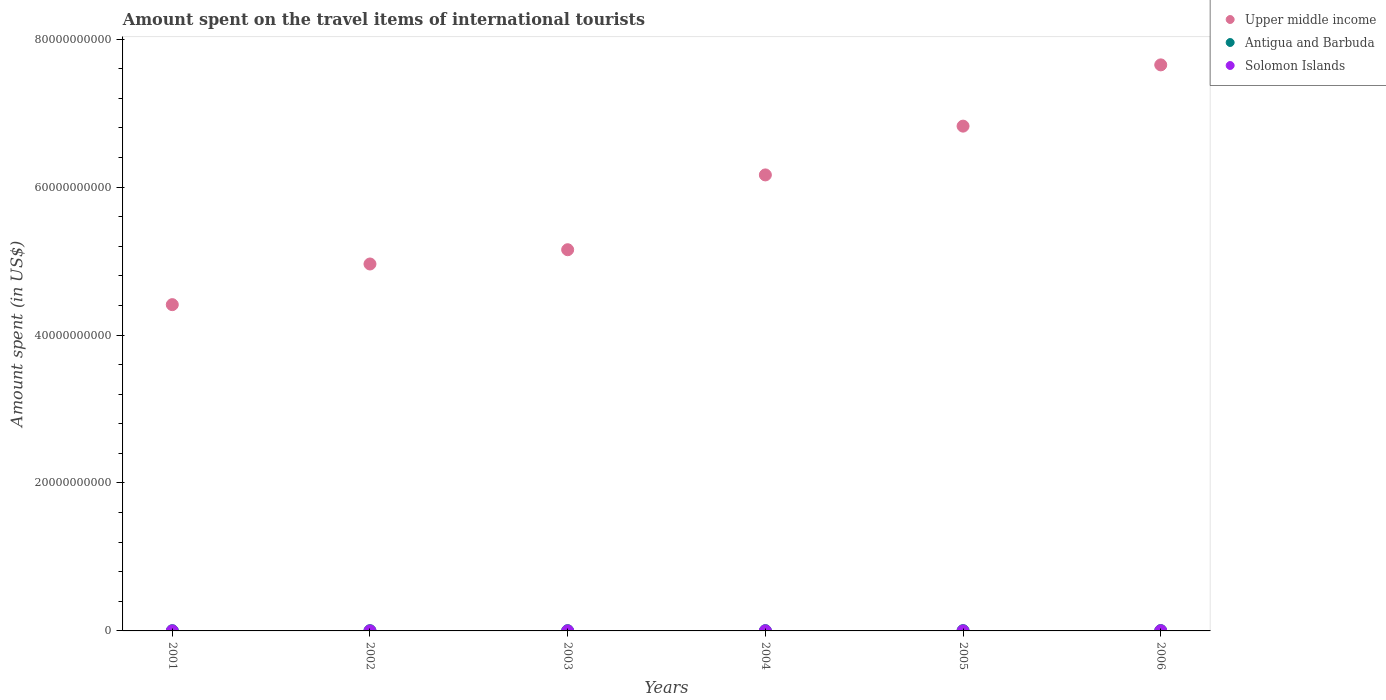What is the amount spent on the travel items of international tourists in Solomon Islands in 2001?
Keep it short and to the point. 6.60e+06. Across all years, what is the maximum amount spent on the travel items of international tourists in Antigua and Barbuda?
Ensure brevity in your answer.  4.50e+07. Across all years, what is the minimum amount spent on the travel items of international tourists in Solomon Islands?
Provide a short and direct response. 4.40e+06. In which year was the amount spent on the travel items of international tourists in Antigua and Barbuda minimum?
Your answer should be compact. 2001. What is the total amount spent on the travel items of international tourists in Antigua and Barbuda in the graph?
Your answer should be very brief. 2.23e+08. What is the difference between the amount spent on the travel items of international tourists in Upper middle income in 2005 and that in 2006?
Your answer should be compact. -8.28e+09. What is the difference between the amount spent on the travel items of international tourists in Antigua and Barbuda in 2004 and the amount spent on the travel items of international tourists in Upper middle income in 2001?
Your answer should be compact. -4.41e+1. What is the average amount spent on the travel items of international tourists in Solomon Islands per year?
Provide a short and direct response. 8.78e+06. In the year 2002, what is the difference between the amount spent on the travel items of international tourists in Solomon Islands and amount spent on the travel items of international tourists in Upper middle income?
Make the answer very short. -4.96e+1. Is the difference between the amount spent on the travel items of international tourists in Solomon Islands in 2003 and 2006 greater than the difference between the amount spent on the travel items of international tourists in Upper middle income in 2003 and 2006?
Your answer should be compact. Yes. What is the difference between the highest and the second highest amount spent on the travel items of international tourists in Upper middle income?
Offer a terse response. 8.28e+09. What is the difference between the highest and the lowest amount spent on the travel items of international tourists in Antigua and Barbuda?
Provide a short and direct response. 1.30e+07. In how many years, is the amount spent on the travel items of international tourists in Upper middle income greater than the average amount spent on the travel items of international tourists in Upper middle income taken over all years?
Ensure brevity in your answer.  3. Is it the case that in every year, the sum of the amount spent on the travel items of international tourists in Antigua and Barbuda and amount spent on the travel items of international tourists in Upper middle income  is greater than the amount spent on the travel items of international tourists in Solomon Islands?
Offer a very short reply. Yes. Does the amount spent on the travel items of international tourists in Upper middle income monotonically increase over the years?
Make the answer very short. Yes. Is the amount spent on the travel items of international tourists in Solomon Islands strictly greater than the amount spent on the travel items of international tourists in Upper middle income over the years?
Offer a terse response. No. How many years are there in the graph?
Ensure brevity in your answer.  6. What is the difference between two consecutive major ticks on the Y-axis?
Keep it short and to the point. 2.00e+1. Are the values on the major ticks of Y-axis written in scientific E-notation?
Ensure brevity in your answer.  No. Does the graph contain any zero values?
Provide a short and direct response. No. What is the title of the graph?
Your response must be concise. Amount spent on the travel items of international tourists. Does "Paraguay" appear as one of the legend labels in the graph?
Your answer should be compact. No. What is the label or title of the Y-axis?
Give a very brief answer. Amount spent (in US$). What is the Amount spent (in US$) of Upper middle income in 2001?
Keep it short and to the point. 4.41e+1. What is the Amount spent (in US$) in Antigua and Barbuda in 2001?
Your answer should be compact. 3.20e+07. What is the Amount spent (in US$) in Solomon Islands in 2001?
Keep it short and to the point. 6.60e+06. What is the Amount spent (in US$) of Upper middle income in 2002?
Provide a short and direct response. 4.96e+1. What is the Amount spent (in US$) of Antigua and Barbuda in 2002?
Provide a succinct answer. 3.30e+07. What is the Amount spent (in US$) of Solomon Islands in 2002?
Your answer should be compact. 5.80e+06. What is the Amount spent (in US$) in Upper middle income in 2003?
Provide a short and direct response. 5.15e+1. What is the Amount spent (in US$) in Antigua and Barbuda in 2003?
Ensure brevity in your answer.  3.50e+07. What is the Amount spent (in US$) in Solomon Islands in 2003?
Offer a very short reply. 4.40e+06. What is the Amount spent (in US$) of Upper middle income in 2004?
Provide a succinct answer. 6.16e+1. What is the Amount spent (in US$) in Antigua and Barbuda in 2004?
Offer a terse response. 3.80e+07. What is the Amount spent (in US$) of Solomon Islands in 2004?
Make the answer very short. 9.00e+06. What is the Amount spent (in US$) in Upper middle income in 2005?
Make the answer very short. 6.82e+1. What is the Amount spent (in US$) of Antigua and Barbuda in 2005?
Offer a very short reply. 4.00e+07. What is the Amount spent (in US$) of Solomon Islands in 2005?
Make the answer very short. 4.70e+06. What is the Amount spent (in US$) of Upper middle income in 2006?
Your response must be concise. 7.65e+1. What is the Amount spent (in US$) in Antigua and Barbuda in 2006?
Keep it short and to the point. 4.50e+07. What is the Amount spent (in US$) in Solomon Islands in 2006?
Your answer should be very brief. 2.22e+07. Across all years, what is the maximum Amount spent (in US$) of Upper middle income?
Give a very brief answer. 7.65e+1. Across all years, what is the maximum Amount spent (in US$) of Antigua and Barbuda?
Keep it short and to the point. 4.50e+07. Across all years, what is the maximum Amount spent (in US$) in Solomon Islands?
Give a very brief answer. 2.22e+07. Across all years, what is the minimum Amount spent (in US$) of Upper middle income?
Keep it short and to the point. 4.41e+1. Across all years, what is the minimum Amount spent (in US$) in Antigua and Barbuda?
Give a very brief answer. 3.20e+07. Across all years, what is the minimum Amount spent (in US$) of Solomon Islands?
Make the answer very short. 4.40e+06. What is the total Amount spent (in US$) in Upper middle income in the graph?
Provide a succinct answer. 3.52e+11. What is the total Amount spent (in US$) of Antigua and Barbuda in the graph?
Give a very brief answer. 2.23e+08. What is the total Amount spent (in US$) in Solomon Islands in the graph?
Offer a very short reply. 5.27e+07. What is the difference between the Amount spent (in US$) of Upper middle income in 2001 and that in 2002?
Make the answer very short. -5.50e+09. What is the difference between the Amount spent (in US$) of Antigua and Barbuda in 2001 and that in 2002?
Ensure brevity in your answer.  -1.00e+06. What is the difference between the Amount spent (in US$) in Solomon Islands in 2001 and that in 2002?
Your answer should be very brief. 8.00e+05. What is the difference between the Amount spent (in US$) in Upper middle income in 2001 and that in 2003?
Provide a succinct answer. -7.43e+09. What is the difference between the Amount spent (in US$) of Antigua and Barbuda in 2001 and that in 2003?
Provide a short and direct response. -3.00e+06. What is the difference between the Amount spent (in US$) of Solomon Islands in 2001 and that in 2003?
Give a very brief answer. 2.20e+06. What is the difference between the Amount spent (in US$) in Upper middle income in 2001 and that in 2004?
Keep it short and to the point. -1.75e+1. What is the difference between the Amount spent (in US$) of Antigua and Barbuda in 2001 and that in 2004?
Offer a terse response. -6.00e+06. What is the difference between the Amount spent (in US$) in Solomon Islands in 2001 and that in 2004?
Offer a terse response. -2.40e+06. What is the difference between the Amount spent (in US$) in Upper middle income in 2001 and that in 2005?
Your answer should be very brief. -2.41e+1. What is the difference between the Amount spent (in US$) of Antigua and Barbuda in 2001 and that in 2005?
Your answer should be compact. -8.00e+06. What is the difference between the Amount spent (in US$) in Solomon Islands in 2001 and that in 2005?
Ensure brevity in your answer.  1.90e+06. What is the difference between the Amount spent (in US$) in Upper middle income in 2001 and that in 2006?
Give a very brief answer. -3.24e+1. What is the difference between the Amount spent (in US$) in Antigua and Barbuda in 2001 and that in 2006?
Provide a short and direct response. -1.30e+07. What is the difference between the Amount spent (in US$) in Solomon Islands in 2001 and that in 2006?
Provide a short and direct response. -1.56e+07. What is the difference between the Amount spent (in US$) in Upper middle income in 2002 and that in 2003?
Ensure brevity in your answer.  -1.93e+09. What is the difference between the Amount spent (in US$) in Solomon Islands in 2002 and that in 2003?
Provide a succinct answer. 1.40e+06. What is the difference between the Amount spent (in US$) in Upper middle income in 2002 and that in 2004?
Provide a succinct answer. -1.20e+1. What is the difference between the Amount spent (in US$) in Antigua and Barbuda in 2002 and that in 2004?
Your response must be concise. -5.00e+06. What is the difference between the Amount spent (in US$) of Solomon Islands in 2002 and that in 2004?
Provide a succinct answer. -3.20e+06. What is the difference between the Amount spent (in US$) in Upper middle income in 2002 and that in 2005?
Provide a succinct answer. -1.86e+1. What is the difference between the Amount spent (in US$) in Antigua and Barbuda in 2002 and that in 2005?
Ensure brevity in your answer.  -7.00e+06. What is the difference between the Amount spent (in US$) in Solomon Islands in 2002 and that in 2005?
Your answer should be compact. 1.10e+06. What is the difference between the Amount spent (in US$) of Upper middle income in 2002 and that in 2006?
Provide a succinct answer. -2.69e+1. What is the difference between the Amount spent (in US$) of Antigua and Barbuda in 2002 and that in 2006?
Offer a terse response. -1.20e+07. What is the difference between the Amount spent (in US$) of Solomon Islands in 2002 and that in 2006?
Your answer should be compact. -1.64e+07. What is the difference between the Amount spent (in US$) of Upper middle income in 2003 and that in 2004?
Your response must be concise. -1.01e+1. What is the difference between the Amount spent (in US$) of Antigua and Barbuda in 2003 and that in 2004?
Offer a very short reply. -3.00e+06. What is the difference between the Amount spent (in US$) in Solomon Islands in 2003 and that in 2004?
Ensure brevity in your answer.  -4.60e+06. What is the difference between the Amount spent (in US$) in Upper middle income in 2003 and that in 2005?
Your answer should be compact. -1.67e+1. What is the difference between the Amount spent (in US$) in Antigua and Barbuda in 2003 and that in 2005?
Your answer should be very brief. -5.00e+06. What is the difference between the Amount spent (in US$) of Upper middle income in 2003 and that in 2006?
Your answer should be very brief. -2.50e+1. What is the difference between the Amount spent (in US$) of Antigua and Barbuda in 2003 and that in 2006?
Keep it short and to the point. -1.00e+07. What is the difference between the Amount spent (in US$) of Solomon Islands in 2003 and that in 2006?
Provide a succinct answer. -1.78e+07. What is the difference between the Amount spent (in US$) in Upper middle income in 2004 and that in 2005?
Give a very brief answer. -6.59e+09. What is the difference between the Amount spent (in US$) of Antigua and Barbuda in 2004 and that in 2005?
Make the answer very short. -2.00e+06. What is the difference between the Amount spent (in US$) in Solomon Islands in 2004 and that in 2005?
Provide a succinct answer. 4.30e+06. What is the difference between the Amount spent (in US$) of Upper middle income in 2004 and that in 2006?
Provide a short and direct response. -1.49e+1. What is the difference between the Amount spent (in US$) of Antigua and Barbuda in 2004 and that in 2006?
Provide a short and direct response. -7.00e+06. What is the difference between the Amount spent (in US$) in Solomon Islands in 2004 and that in 2006?
Keep it short and to the point. -1.32e+07. What is the difference between the Amount spent (in US$) of Upper middle income in 2005 and that in 2006?
Ensure brevity in your answer.  -8.28e+09. What is the difference between the Amount spent (in US$) in Antigua and Barbuda in 2005 and that in 2006?
Your answer should be compact. -5.00e+06. What is the difference between the Amount spent (in US$) of Solomon Islands in 2005 and that in 2006?
Your response must be concise. -1.75e+07. What is the difference between the Amount spent (in US$) of Upper middle income in 2001 and the Amount spent (in US$) of Antigua and Barbuda in 2002?
Your answer should be very brief. 4.41e+1. What is the difference between the Amount spent (in US$) in Upper middle income in 2001 and the Amount spent (in US$) in Solomon Islands in 2002?
Your answer should be very brief. 4.41e+1. What is the difference between the Amount spent (in US$) in Antigua and Barbuda in 2001 and the Amount spent (in US$) in Solomon Islands in 2002?
Make the answer very short. 2.62e+07. What is the difference between the Amount spent (in US$) in Upper middle income in 2001 and the Amount spent (in US$) in Antigua and Barbuda in 2003?
Provide a succinct answer. 4.41e+1. What is the difference between the Amount spent (in US$) of Upper middle income in 2001 and the Amount spent (in US$) of Solomon Islands in 2003?
Provide a succinct answer. 4.41e+1. What is the difference between the Amount spent (in US$) in Antigua and Barbuda in 2001 and the Amount spent (in US$) in Solomon Islands in 2003?
Ensure brevity in your answer.  2.76e+07. What is the difference between the Amount spent (in US$) in Upper middle income in 2001 and the Amount spent (in US$) in Antigua and Barbuda in 2004?
Your answer should be very brief. 4.41e+1. What is the difference between the Amount spent (in US$) in Upper middle income in 2001 and the Amount spent (in US$) in Solomon Islands in 2004?
Offer a very short reply. 4.41e+1. What is the difference between the Amount spent (in US$) of Antigua and Barbuda in 2001 and the Amount spent (in US$) of Solomon Islands in 2004?
Keep it short and to the point. 2.30e+07. What is the difference between the Amount spent (in US$) of Upper middle income in 2001 and the Amount spent (in US$) of Antigua and Barbuda in 2005?
Make the answer very short. 4.41e+1. What is the difference between the Amount spent (in US$) of Upper middle income in 2001 and the Amount spent (in US$) of Solomon Islands in 2005?
Make the answer very short. 4.41e+1. What is the difference between the Amount spent (in US$) in Antigua and Barbuda in 2001 and the Amount spent (in US$) in Solomon Islands in 2005?
Keep it short and to the point. 2.73e+07. What is the difference between the Amount spent (in US$) in Upper middle income in 2001 and the Amount spent (in US$) in Antigua and Barbuda in 2006?
Offer a terse response. 4.41e+1. What is the difference between the Amount spent (in US$) of Upper middle income in 2001 and the Amount spent (in US$) of Solomon Islands in 2006?
Provide a short and direct response. 4.41e+1. What is the difference between the Amount spent (in US$) in Antigua and Barbuda in 2001 and the Amount spent (in US$) in Solomon Islands in 2006?
Offer a very short reply. 9.80e+06. What is the difference between the Amount spent (in US$) in Upper middle income in 2002 and the Amount spent (in US$) in Antigua and Barbuda in 2003?
Ensure brevity in your answer.  4.96e+1. What is the difference between the Amount spent (in US$) of Upper middle income in 2002 and the Amount spent (in US$) of Solomon Islands in 2003?
Make the answer very short. 4.96e+1. What is the difference between the Amount spent (in US$) in Antigua and Barbuda in 2002 and the Amount spent (in US$) in Solomon Islands in 2003?
Your answer should be compact. 2.86e+07. What is the difference between the Amount spent (in US$) in Upper middle income in 2002 and the Amount spent (in US$) in Antigua and Barbuda in 2004?
Give a very brief answer. 4.96e+1. What is the difference between the Amount spent (in US$) of Upper middle income in 2002 and the Amount spent (in US$) of Solomon Islands in 2004?
Your response must be concise. 4.96e+1. What is the difference between the Amount spent (in US$) of Antigua and Barbuda in 2002 and the Amount spent (in US$) of Solomon Islands in 2004?
Your response must be concise. 2.40e+07. What is the difference between the Amount spent (in US$) of Upper middle income in 2002 and the Amount spent (in US$) of Antigua and Barbuda in 2005?
Make the answer very short. 4.96e+1. What is the difference between the Amount spent (in US$) in Upper middle income in 2002 and the Amount spent (in US$) in Solomon Islands in 2005?
Provide a short and direct response. 4.96e+1. What is the difference between the Amount spent (in US$) of Antigua and Barbuda in 2002 and the Amount spent (in US$) of Solomon Islands in 2005?
Make the answer very short. 2.83e+07. What is the difference between the Amount spent (in US$) in Upper middle income in 2002 and the Amount spent (in US$) in Antigua and Barbuda in 2006?
Your answer should be very brief. 4.96e+1. What is the difference between the Amount spent (in US$) in Upper middle income in 2002 and the Amount spent (in US$) in Solomon Islands in 2006?
Offer a very short reply. 4.96e+1. What is the difference between the Amount spent (in US$) in Antigua and Barbuda in 2002 and the Amount spent (in US$) in Solomon Islands in 2006?
Give a very brief answer. 1.08e+07. What is the difference between the Amount spent (in US$) of Upper middle income in 2003 and the Amount spent (in US$) of Antigua and Barbuda in 2004?
Make the answer very short. 5.15e+1. What is the difference between the Amount spent (in US$) of Upper middle income in 2003 and the Amount spent (in US$) of Solomon Islands in 2004?
Provide a succinct answer. 5.15e+1. What is the difference between the Amount spent (in US$) of Antigua and Barbuda in 2003 and the Amount spent (in US$) of Solomon Islands in 2004?
Your response must be concise. 2.60e+07. What is the difference between the Amount spent (in US$) of Upper middle income in 2003 and the Amount spent (in US$) of Antigua and Barbuda in 2005?
Your answer should be very brief. 5.15e+1. What is the difference between the Amount spent (in US$) in Upper middle income in 2003 and the Amount spent (in US$) in Solomon Islands in 2005?
Your response must be concise. 5.15e+1. What is the difference between the Amount spent (in US$) of Antigua and Barbuda in 2003 and the Amount spent (in US$) of Solomon Islands in 2005?
Your answer should be compact. 3.03e+07. What is the difference between the Amount spent (in US$) in Upper middle income in 2003 and the Amount spent (in US$) in Antigua and Barbuda in 2006?
Provide a short and direct response. 5.15e+1. What is the difference between the Amount spent (in US$) of Upper middle income in 2003 and the Amount spent (in US$) of Solomon Islands in 2006?
Make the answer very short. 5.15e+1. What is the difference between the Amount spent (in US$) in Antigua and Barbuda in 2003 and the Amount spent (in US$) in Solomon Islands in 2006?
Offer a very short reply. 1.28e+07. What is the difference between the Amount spent (in US$) of Upper middle income in 2004 and the Amount spent (in US$) of Antigua and Barbuda in 2005?
Your response must be concise. 6.16e+1. What is the difference between the Amount spent (in US$) of Upper middle income in 2004 and the Amount spent (in US$) of Solomon Islands in 2005?
Your response must be concise. 6.16e+1. What is the difference between the Amount spent (in US$) of Antigua and Barbuda in 2004 and the Amount spent (in US$) of Solomon Islands in 2005?
Offer a very short reply. 3.33e+07. What is the difference between the Amount spent (in US$) in Upper middle income in 2004 and the Amount spent (in US$) in Antigua and Barbuda in 2006?
Make the answer very short. 6.16e+1. What is the difference between the Amount spent (in US$) of Upper middle income in 2004 and the Amount spent (in US$) of Solomon Islands in 2006?
Make the answer very short. 6.16e+1. What is the difference between the Amount spent (in US$) in Antigua and Barbuda in 2004 and the Amount spent (in US$) in Solomon Islands in 2006?
Ensure brevity in your answer.  1.58e+07. What is the difference between the Amount spent (in US$) of Upper middle income in 2005 and the Amount spent (in US$) of Antigua and Barbuda in 2006?
Offer a terse response. 6.82e+1. What is the difference between the Amount spent (in US$) of Upper middle income in 2005 and the Amount spent (in US$) of Solomon Islands in 2006?
Keep it short and to the point. 6.82e+1. What is the difference between the Amount spent (in US$) of Antigua and Barbuda in 2005 and the Amount spent (in US$) of Solomon Islands in 2006?
Offer a very short reply. 1.78e+07. What is the average Amount spent (in US$) of Upper middle income per year?
Your response must be concise. 5.86e+1. What is the average Amount spent (in US$) in Antigua and Barbuda per year?
Ensure brevity in your answer.  3.72e+07. What is the average Amount spent (in US$) of Solomon Islands per year?
Your response must be concise. 8.78e+06. In the year 2001, what is the difference between the Amount spent (in US$) in Upper middle income and Amount spent (in US$) in Antigua and Barbuda?
Your answer should be compact. 4.41e+1. In the year 2001, what is the difference between the Amount spent (in US$) of Upper middle income and Amount spent (in US$) of Solomon Islands?
Offer a terse response. 4.41e+1. In the year 2001, what is the difference between the Amount spent (in US$) in Antigua and Barbuda and Amount spent (in US$) in Solomon Islands?
Provide a succinct answer. 2.54e+07. In the year 2002, what is the difference between the Amount spent (in US$) of Upper middle income and Amount spent (in US$) of Antigua and Barbuda?
Your answer should be very brief. 4.96e+1. In the year 2002, what is the difference between the Amount spent (in US$) of Upper middle income and Amount spent (in US$) of Solomon Islands?
Provide a succinct answer. 4.96e+1. In the year 2002, what is the difference between the Amount spent (in US$) of Antigua and Barbuda and Amount spent (in US$) of Solomon Islands?
Your response must be concise. 2.72e+07. In the year 2003, what is the difference between the Amount spent (in US$) of Upper middle income and Amount spent (in US$) of Antigua and Barbuda?
Your response must be concise. 5.15e+1. In the year 2003, what is the difference between the Amount spent (in US$) in Upper middle income and Amount spent (in US$) in Solomon Islands?
Give a very brief answer. 5.15e+1. In the year 2003, what is the difference between the Amount spent (in US$) in Antigua and Barbuda and Amount spent (in US$) in Solomon Islands?
Provide a succinct answer. 3.06e+07. In the year 2004, what is the difference between the Amount spent (in US$) in Upper middle income and Amount spent (in US$) in Antigua and Barbuda?
Your answer should be compact. 6.16e+1. In the year 2004, what is the difference between the Amount spent (in US$) of Upper middle income and Amount spent (in US$) of Solomon Islands?
Provide a succinct answer. 6.16e+1. In the year 2004, what is the difference between the Amount spent (in US$) in Antigua and Barbuda and Amount spent (in US$) in Solomon Islands?
Give a very brief answer. 2.90e+07. In the year 2005, what is the difference between the Amount spent (in US$) of Upper middle income and Amount spent (in US$) of Antigua and Barbuda?
Offer a very short reply. 6.82e+1. In the year 2005, what is the difference between the Amount spent (in US$) in Upper middle income and Amount spent (in US$) in Solomon Islands?
Provide a succinct answer. 6.82e+1. In the year 2005, what is the difference between the Amount spent (in US$) of Antigua and Barbuda and Amount spent (in US$) of Solomon Islands?
Your answer should be very brief. 3.53e+07. In the year 2006, what is the difference between the Amount spent (in US$) in Upper middle income and Amount spent (in US$) in Antigua and Barbuda?
Ensure brevity in your answer.  7.65e+1. In the year 2006, what is the difference between the Amount spent (in US$) in Upper middle income and Amount spent (in US$) in Solomon Islands?
Offer a terse response. 7.65e+1. In the year 2006, what is the difference between the Amount spent (in US$) in Antigua and Barbuda and Amount spent (in US$) in Solomon Islands?
Keep it short and to the point. 2.28e+07. What is the ratio of the Amount spent (in US$) in Upper middle income in 2001 to that in 2002?
Provide a succinct answer. 0.89. What is the ratio of the Amount spent (in US$) of Antigua and Barbuda in 2001 to that in 2002?
Your answer should be very brief. 0.97. What is the ratio of the Amount spent (in US$) in Solomon Islands in 2001 to that in 2002?
Make the answer very short. 1.14. What is the ratio of the Amount spent (in US$) in Upper middle income in 2001 to that in 2003?
Ensure brevity in your answer.  0.86. What is the ratio of the Amount spent (in US$) in Antigua and Barbuda in 2001 to that in 2003?
Your response must be concise. 0.91. What is the ratio of the Amount spent (in US$) in Upper middle income in 2001 to that in 2004?
Offer a terse response. 0.72. What is the ratio of the Amount spent (in US$) of Antigua and Barbuda in 2001 to that in 2004?
Offer a very short reply. 0.84. What is the ratio of the Amount spent (in US$) in Solomon Islands in 2001 to that in 2004?
Offer a terse response. 0.73. What is the ratio of the Amount spent (in US$) in Upper middle income in 2001 to that in 2005?
Ensure brevity in your answer.  0.65. What is the ratio of the Amount spent (in US$) in Solomon Islands in 2001 to that in 2005?
Offer a very short reply. 1.4. What is the ratio of the Amount spent (in US$) in Upper middle income in 2001 to that in 2006?
Your response must be concise. 0.58. What is the ratio of the Amount spent (in US$) in Antigua and Barbuda in 2001 to that in 2006?
Your response must be concise. 0.71. What is the ratio of the Amount spent (in US$) in Solomon Islands in 2001 to that in 2006?
Offer a terse response. 0.3. What is the ratio of the Amount spent (in US$) of Upper middle income in 2002 to that in 2003?
Provide a succinct answer. 0.96. What is the ratio of the Amount spent (in US$) of Antigua and Barbuda in 2002 to that in 2003?
Your answer should be very brief. 0.94. What is the ratio of the Amount spent (in US$) of Solomon Islands in 2002 to that in 2003?
Give a very brief answer. 1.32. What is the ratio of the Amount spent (in US$) of Upper middle income in 2002 to that in 2004?
Ensure brevity in your answer.  0.8. What is the ratio of the Amount spent (in US$) of Antigua and Barbuda in 2002 to that in 2004?
Offer a very short reply. 0.87. What is the ratio of the Amount spent (in US$) in Solomon Islands in 2002 to that in 2004?
Offer a very short reply. 0.64. What is the ratio of the Amount spent (in US$) in Upper middle income in 2002 to that in 2005?
Provide a succinct answer. 0.73. What is the ratio of the Amount spent (in US$) in Antigua and Barbuda in 2002 to that in 2005?
Your answer should be very brief. 0.82. What is the ratio of the Amount spent (in US$) of Solomon Islands in 2002 to that in 2005?
Make the answer very short. 1.23. What is the ratio of the Amount spent (in US$) of Upper middle income in 2002 to that in 2006?
Offer a very short reply. 0.65. What is the ratio of the Amount spent (in US$) in Antigua and Barbuda in 2002 to that in 2006?
Keep it short and to the point. 0.73. What is the ratio of the Amount spent (in US$) of Solomon Islands in 2002 to that in 2006?
Your answer should be very brief. 0.26. What is the ratio of the Amount spent (in US$) of Upper middle income in 2003 to that in 2004?
Offer a very short reply. 0.84. What is the ratio of the Amount spent (in US$) in Antigua and Barbuda in 2003 to that in 2004?
Give a very brief answer. 0.92. What is the ratio of the Amount spent (in US$) in Solomon Islands in 2003 to that in 2004?
Provide a short and direct response. 0.49. What is the ratio of the Amount spent (in US$) in Upper middle income in 2003 to that in 2005?
Your answer should be very brief. 0.76. What is the ratio of the Amount spent (in US$) in Antigua and Barbuda in 2003 to that in 2005?
Provide a short and direct response. 0.88. What is the ratio of the Amount spent (in US$) of Solomon Islands in 2003 to that in 2005?
Keep it short and to the point. 0.94. What is the ratio of the Amount spent (in US$) in Upper middle income in 2003 to that in 2006?
Your answer should be compact. 0.67. What is the ratio of the Amount spent (in US$) in Antigua and Barbuda in 2003 to that in 2006?
Ensure brevity in your answer.  0.78. What is the ratio of the Amount spent (in US$) in Solomon Islands in 2003 to that in 2006?
Offer a very short reply. 0.2. What is the ratio of the Amount spent (in US$) of Upper middle income in 2004 to that in 2005?
Your answer should be very brief. 0.9. What is the ratio of the Amount spent (in US$) of Solomon Islands in 2004 to that in 2005?
Make the answer very short. 1.91. What is the ratio of the Amount spent (in US$) in Upper middle income in 2004 to that in 2006?
Provide a short and direct response. 0.81. What is the ratio of the Amount spent (in US$) in Antigua and Barbuda in 2004 to that in 2006?
Your answer should be compact. 0.84. What is the ratio of the Amount spent (in US$) of Solomon Islands in 2004 to that in 2006?
Make the answer very short. 0.41. What is the ratio of the Amount spent (in US$) in Upper middle income in 2005 to that in 2006?
Make the answer very short. 0.89. What is the ratio of the Amount spent (in US$) of Antigua and Barbuda in 2005 to that in 2006?
Make the answer very short. 0.89. What is the ratio of the Amount spent (in US$) of Solomon Islands in 2005 to that in 2006?
Your answer should be very brief. 0.21. What is the difference between the highest and the second highest Amount spent (in US$) in Upper middle income?
Keep it short and to the point. 8.28e+09. What is the difference between the highest and the second highest Amount spent (in US$) of Solomon Islands?
Give a very brief answer. 1.32e+07. What is the difference between the highest and the lowest Amount spent (in US$) in Upper middle income?
Your answer should be compact. 3.24e+1. What is the difference between the highest and the lowest Amount spent (in US$) of Antigua and Barbuda?
Make the answer very short. 1.30e+07. What is the difference between the highest and the lowest Amount spent (in US$) of Solomon Islands?
Your answer should be very brief. 1.78e+07. 